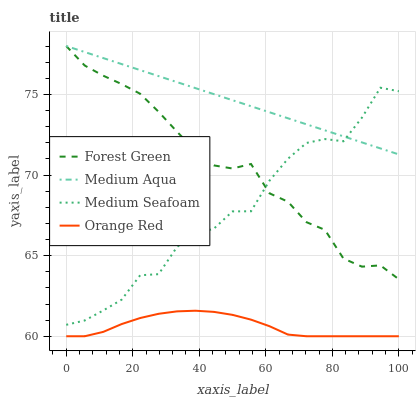Does Orange Red have the minimum area under the curve?
Answer yes or no. Yes. Does Medium Aqua have the maximum area under the curve?
Answer yes or no. Yes. Does Medium Seafoam have the minimum area under the curve?
Answer yes or no. No. Does Medium Seafoam have the maximum area under the curve?
Answer yes or no. No. Is Medium Aqua the smoothest?
Answer yes or no. Yes. Is Medium Seafoam the roughest?
Answer yes or no. Yes. Is Medium Seafoam the smoothest?
Answer yes or no. No. Is Medium Aqua the roughest?
Answer yes or no. No. Does Orange Red have the lowest value?
Answer yes or no. Yes. Does Medium Seafoam have the lowest value?
Answer yes or no. No. Does Medium Aqua have the highest value?
Answer yes or no. Yes. Does Medium Seafoam have the highest value?
Answer yes or no. No. Is Orange Red less than Forest Green?
Answer yes or no. Yes. Is Forest Green greater than Orange Red?
Answer yes or no. Yes. Does Forest Green intersect Medium Aqua?
Answer yes or no. Yes. Is Forest Green less than Medium Aqua?
Answer yes or no. No. Is Forest Green greater than Medium Aqua?
Answer yes or no. No. Does Orange Red intersect Forest Green?
Answer yes or no. No. 